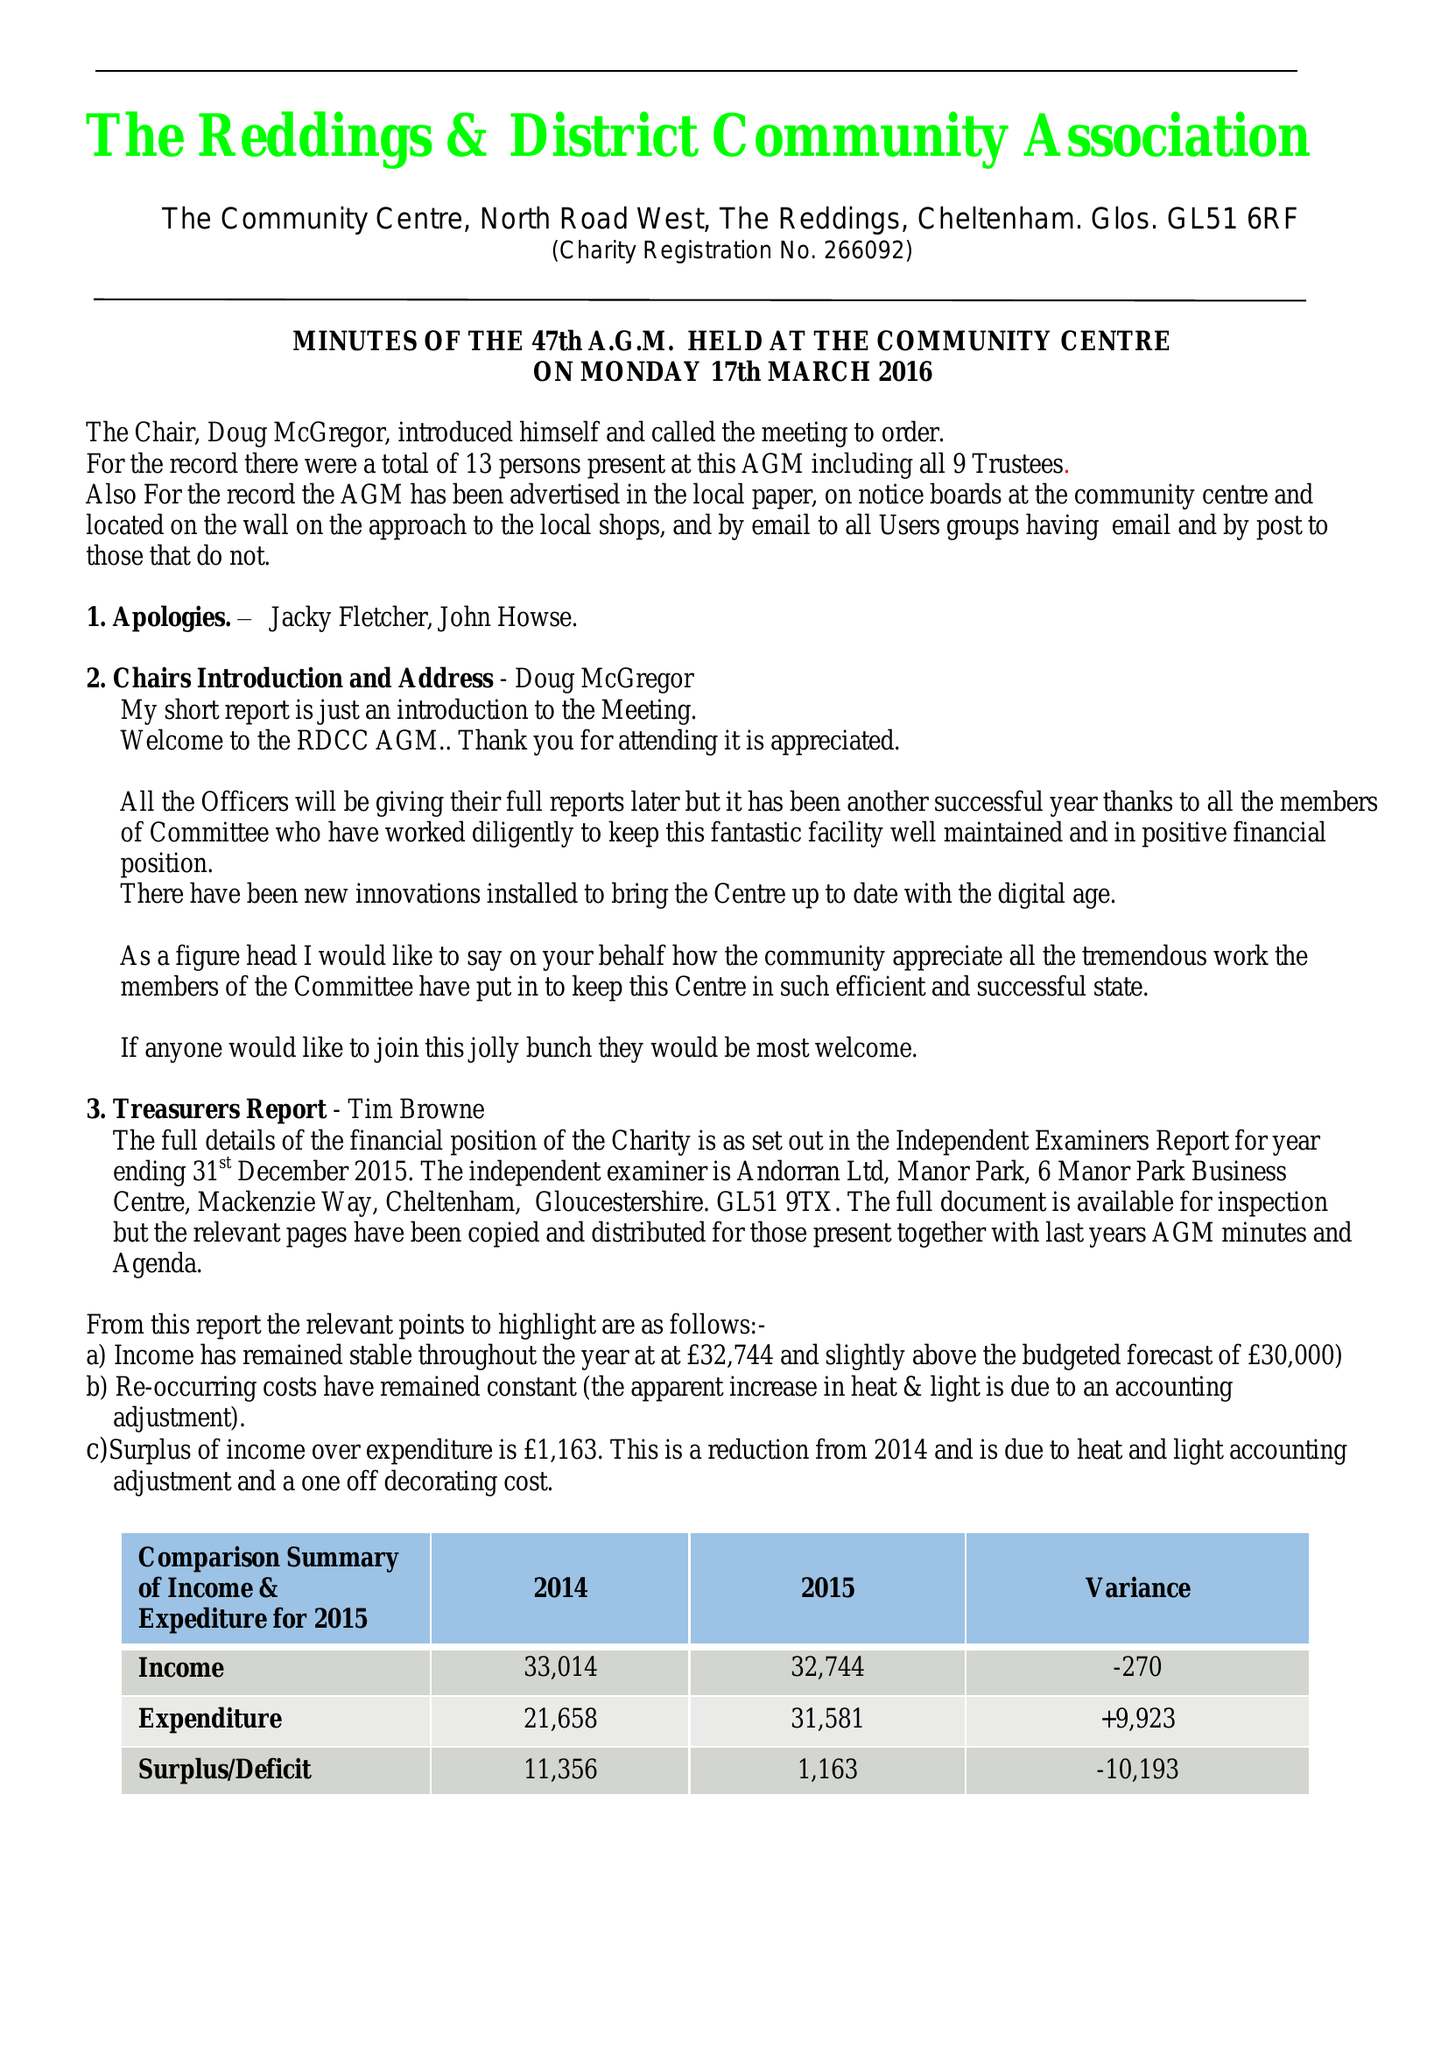What is the value for the address__postcode?
Answer the question using a single word or phrase. GL51 6RF 